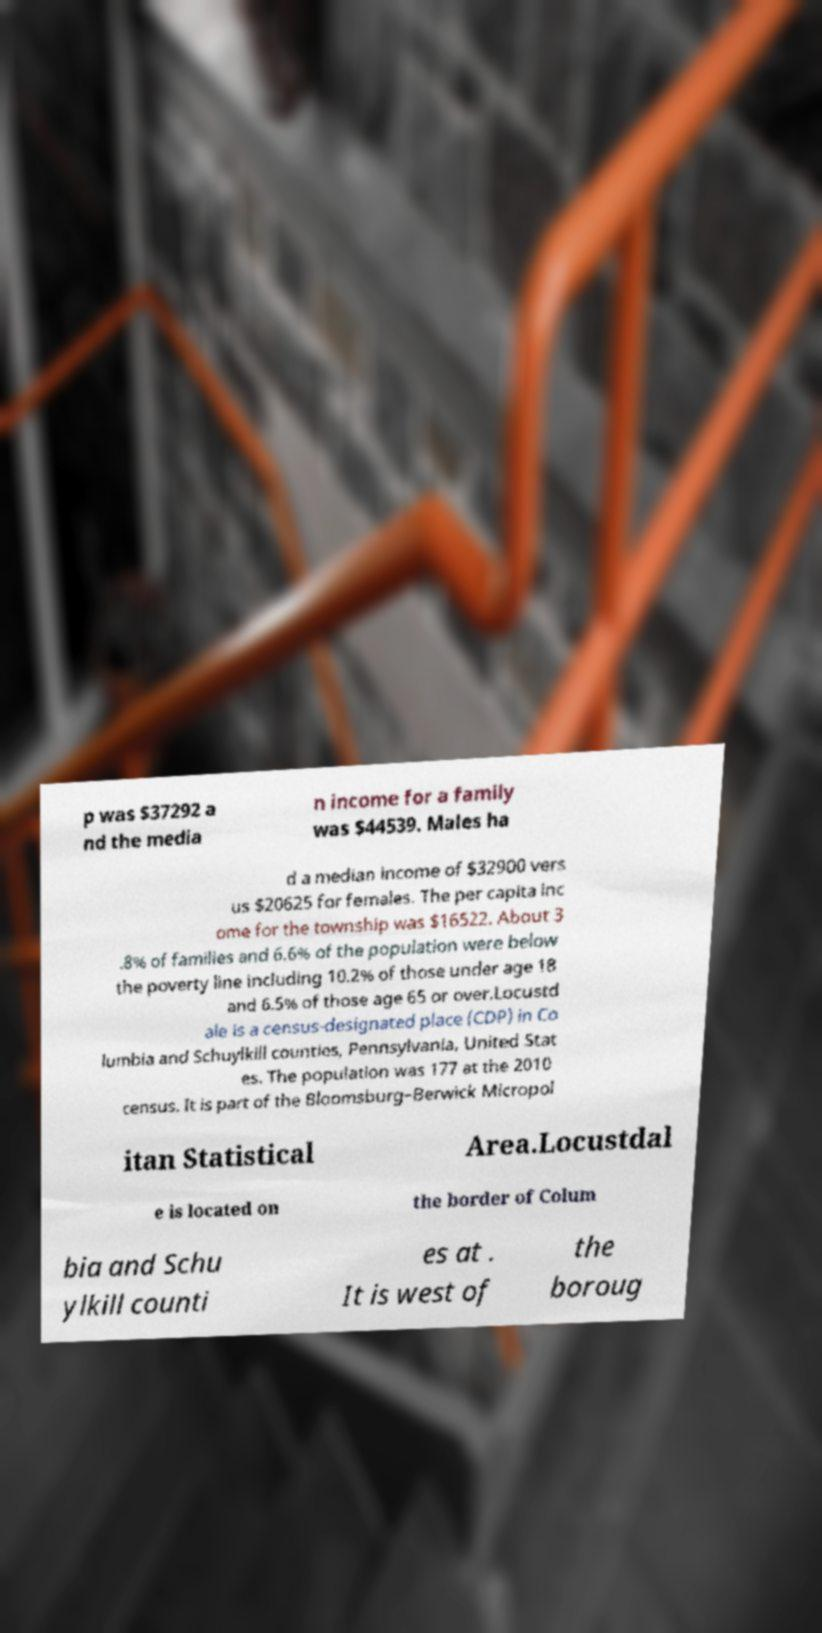Could you assist in decoding the text presented in this image and type it out clearly? p was $37292 a nd the media n income for a family was $44539. Males ha d a median income of $32900 vers us $20625 for females. The per capita inc ome for the township was $16522. About 3 .8% of families and 6.6% of the population were below the poverty line including 10.2% of those under age 18 and 6.5% of those age 65 or over.Locustd ale is a census-designated place (CDP) in Co lumbia and Schuylkill counties, Pennsylvania, United Stat es. The population was 177 at the 2010 census. It is part of the Bloomsburg–Berwick Micropol itan Statistical Area.Locustdal e is located on the border of Colum bia and Schu ylkill counti es at . It is west of the boroug 